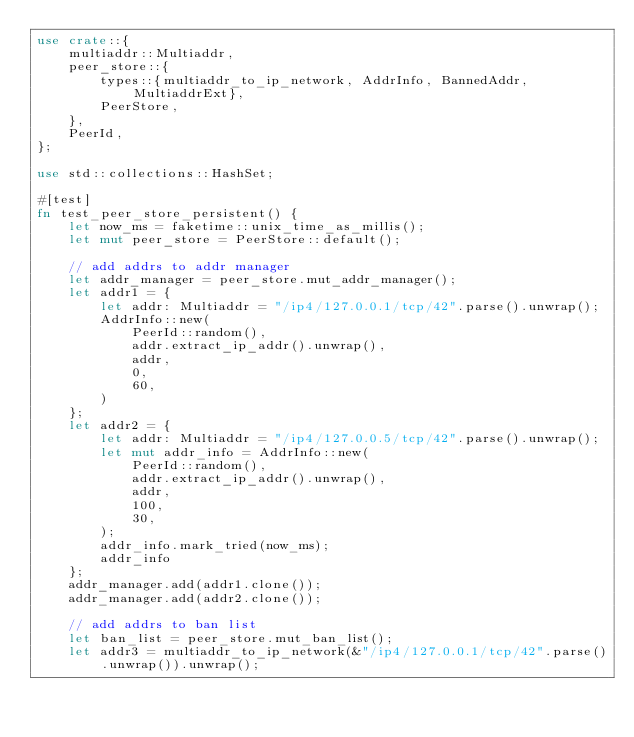<code> <loc_0><loc_0><loc_500><loc_500><_Rust_>use crate::{
    multiaddr::Multiaddr,
    peer_store::{
        types::{multiaddr_to_ip_network, AddrInfo, BannedAddr, MultiaddrExt},
        PeerStore,
    },
    PeerId,
};

use std::collections::HashSet;

#[test]
fn test_peer_store_persistent() {
    let now_ms = faketime::unix_time_as_millis();
    let mut peer_store = PeerStore::default();

    // add addrs to addr manager
    let addr_manager = peer_store.mut_addr_manager();
    let addr1 = {
        let addr: Multiaddr = "/ip4/127.0.0.1/tcp/42".parse().unwrap();
        AddrInfo::new(
            PeerId::random(),
            addr.extract_ip_addr().unwrap(),
            addr,
            0,
            60,
        )
    };
    let addr2 = {
        let addr: Multiaddr = "/ip4/127.0.0.5/tcp/42".parse().unwrap();
        let mut addr_info = AddrInfo::new(
            PeerId::random(),
            addr.extract_ip_addr().unwrap(),
            addr,
            100,
            30,
        );
        addr_info.mark_tried(now_ms);
        addr_info
    };
    addr_manager.add(addr1.clone());
    addr_manager.add(addr2.clone());

    // add addrs to ban list
    let ban_list = peer_store.mut_ban_list();
    let addr3 = multiaddr_to_ip_network(&"/ip4/127.0.0.1/tcp/42".parse().unwrap()).unwrap();</code> 